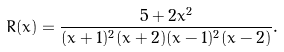Convert formula to latex. <formula><loc_0><loc_0><loc_500><loc_500>R ( x ) = \frac { 5 + 2 x ^ { 2 } } { ( x + 1 ) ^ { 2 } ( x + 2 ) ( x - 1 ) ^ { 2 } ( x - 2 ) } .</formula> 